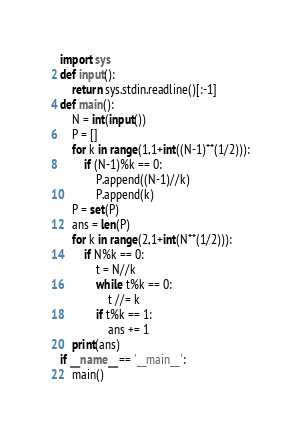Convert code to text. <code><loc_0><loc_0><loc_500><loc_500><_Python_>import sys
def input():
    return sys.stdin.readline()[:-1]
def main():
    N = int(input())
    P = []
    for k in range(1,1+int((N-1)**(1/2))):
        if (N-1)%k == 0:
            P.append((N-1)//k)
            P.append(k)
    P = set(P)
    ans = len(P)
    for k in range(2,1+int(N**(1/2))):
        if N%k == 0:
            t = N//k
            while t%k == 0:
                t //= k
            if t%k == 1:
                ans += 1
    print(ans)
if __name__ == '__main__':
    main()
</code> 